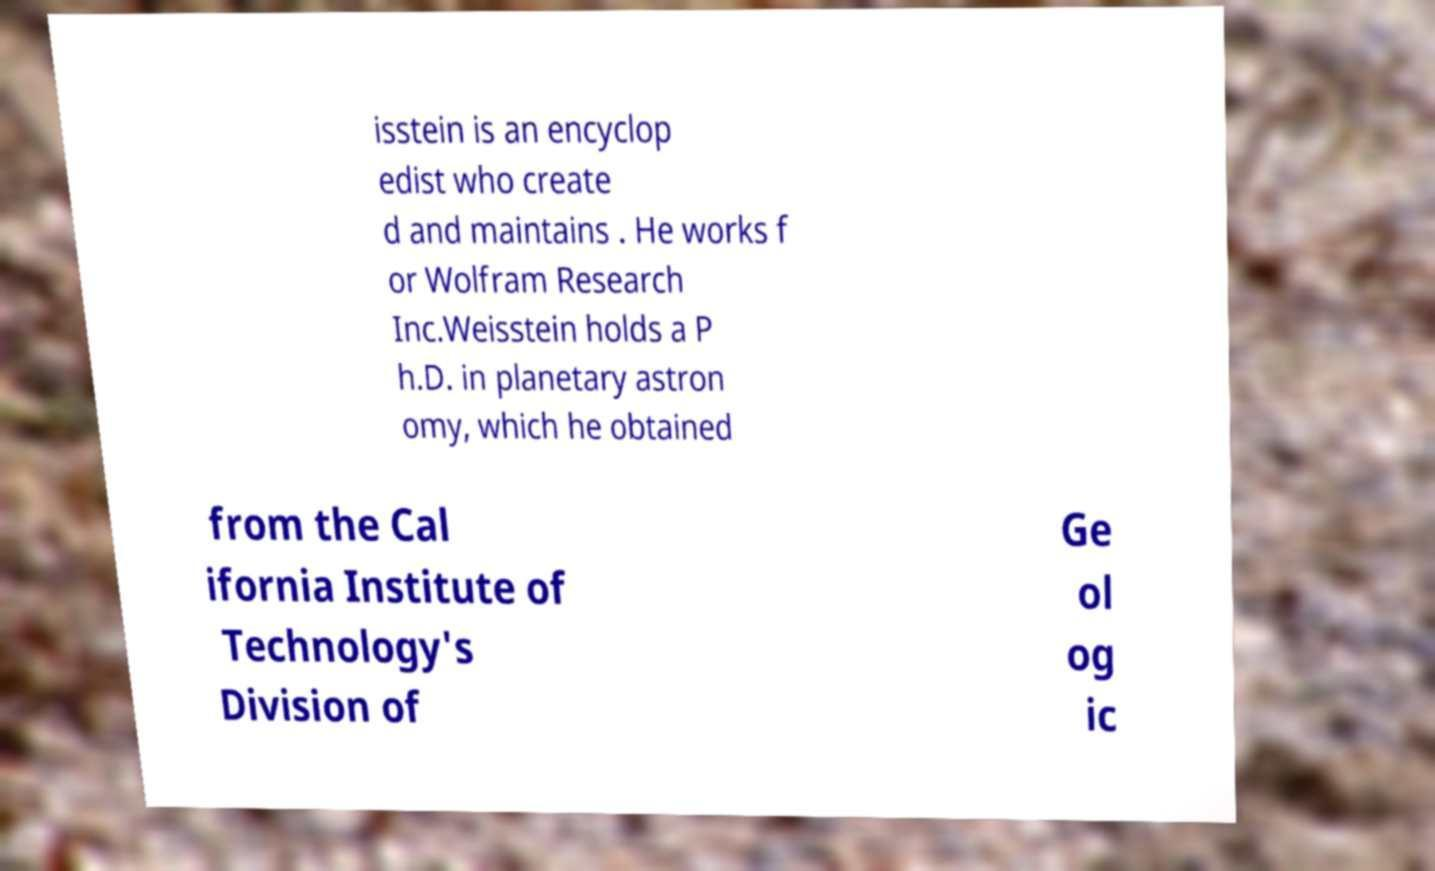Could you extract and type out the text from this image? isstein is an encyclop edist who create d and maintains . He works f or Wolfram Research Inc.Weisstein holds a P h.D. in planetary astron omy, which he obtained from the Cal ifornia Institute of Technology's Division of Ge ol og ic 